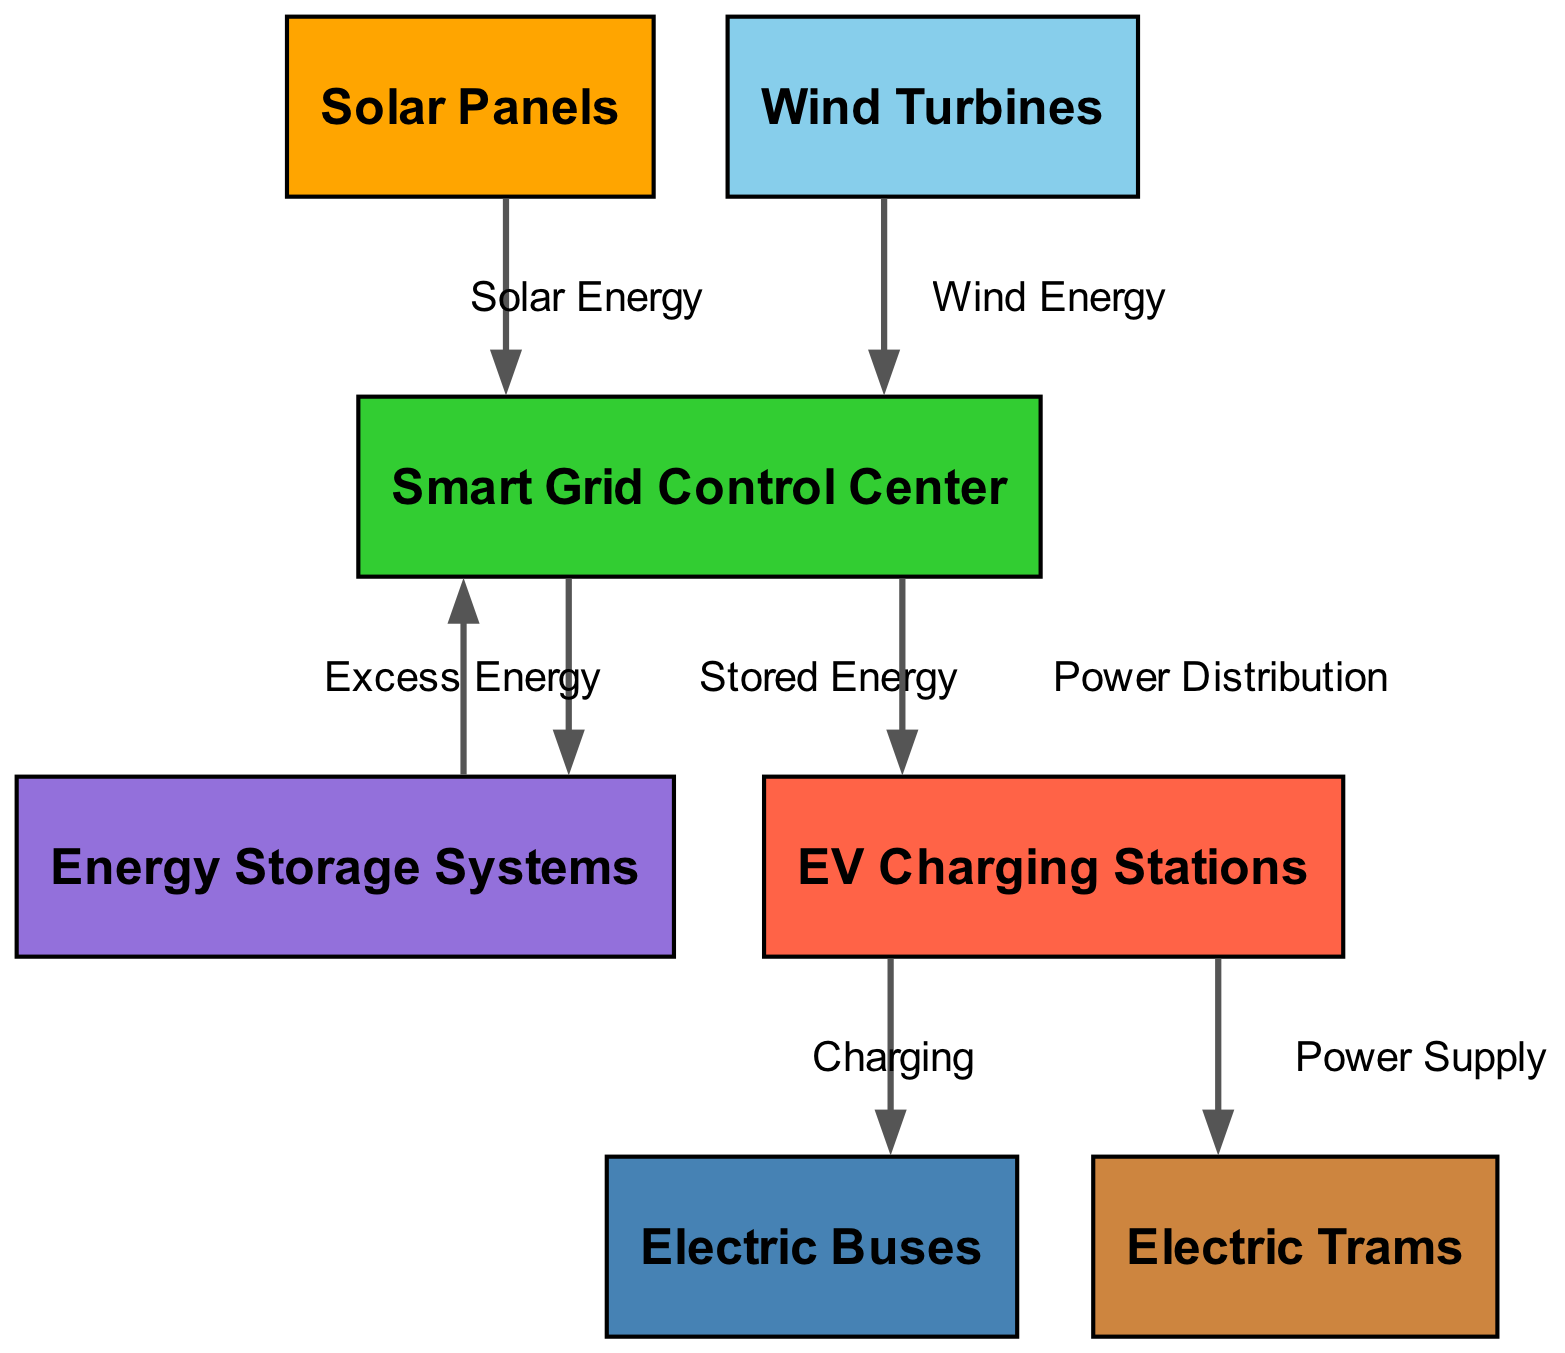What are the energy sources shown in the diagram? The diagram displays two energy sources: solar panels and wind turbines. These are the initial nodes that provide renewable energy input to the smart grid system.
Answer: Solar Panels, Wind Turbines How many nodes are in the diagram? By counting the unique nodes illustrated, we identify seven distinct components in the system, including both energy sources and transportation elements.
Answer: 7 What type of energy do the solar panels supply? The diagram indicates that solar panels contribute solar energy to the smart grid, as represented by the directed edge labeled 'Solar Energy.'
Answer: Solar Energy Which components receive energy directly from the smart grid? The smart grid distributes energy to both the energy storage systems and the charging stations, as shown by the arrows leading from the smart grid to these nodes.
Answer: Energy Storage Systems, EV Charging Stations What is the function of energy storage systems in the diagram? Energy storage systems are tied to the smart grid, receiving excess energy when available and providing stored energy back when needed, highlighting their dual role in energy management.
Answer: Excess Energy, Stored Energy How many edges connect the nodes in the diagram? The edges represent the relationships between the different nodes. By counting the connections, we see there are six edges that represent various energy flows and distributions in the system.
Answer: 6 Which nodes are powered by charging stations? The diagram shows that both electric buses and trams are powered directly by charging stations, as indicated by the edges labeled 'Charging' and 'Power Supply.'
Answer: Electric Buses, Trams What is the purpose of the smart grid control center? The smart grid control center receives energy from renewable sources, manages energy distribution to storage and charging stations, and plays a crucial role in balancing energy supply and demand across the network.
Answer: Energy Management What type of energy do wind turbines supply? Wind turbines contribute wind energy to the smart grid, similar to how solar panels provide solar energy, as clearly represented in the diagram.
Answer: Wind Energy 